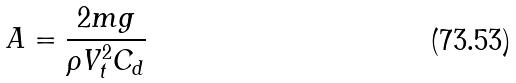Convert formula to latex. <formula><loc_0><loc_0><loc_500><loc_500>A = \frac { 2 m g } { \rho V _ { t } ^ { 2 } C _ { d } }</formula> 